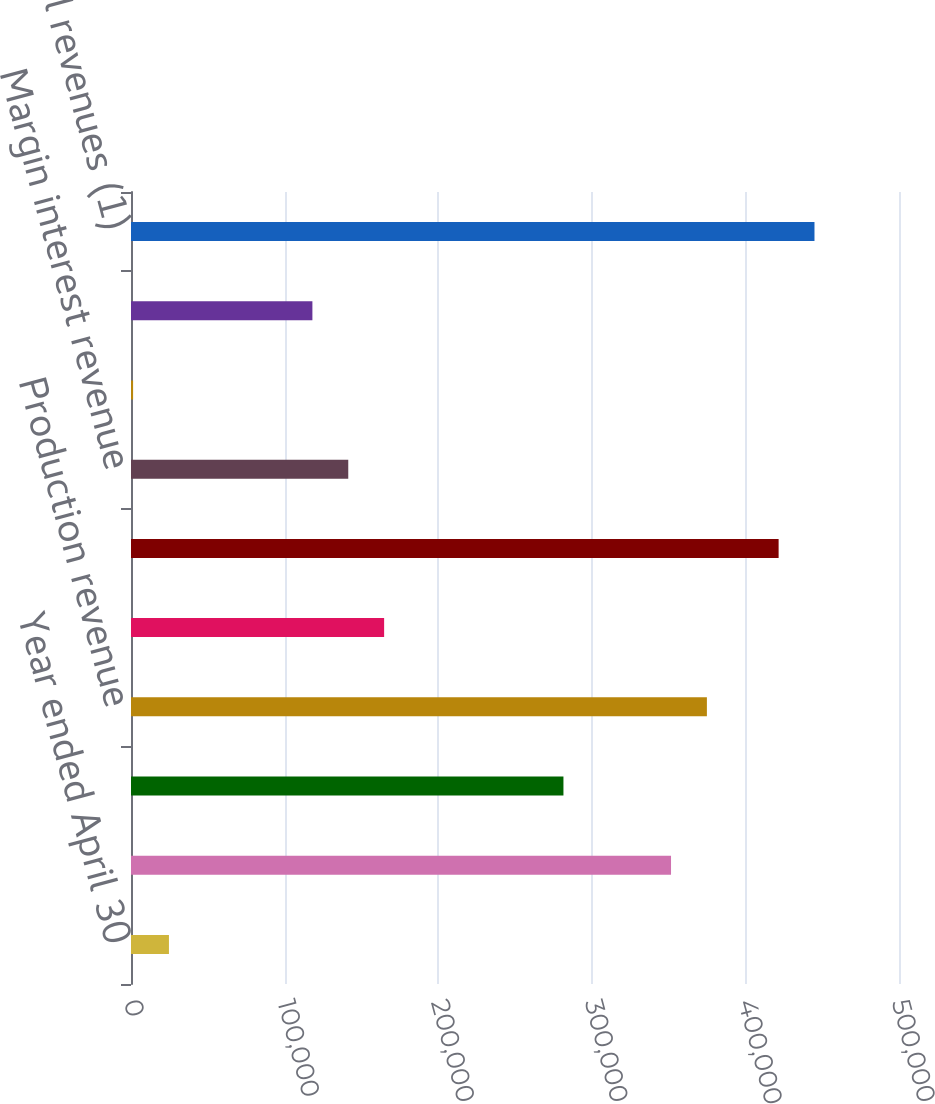Convert chart. <chart><loc_0><loc_0><loc_500><loc_500><bar_chart><fcel>Year ended April 30<fcel>Transactional revenue<fcel>Annuitized revenue<fcel>Production revenue<fcel>Other revenue<fcel>Non-interest revenue<fcel>Margin interest revenue<fcel>Less interest expense<fcel>Net interest revenue<fcel>Total revenues (1)<nl><fcel>24706.3<fcel>351582<fcel>281538<fcel>374931<fcel>164796<fcel>421627<fcel>141448<fcel>1358<fcel>118100<fcel>444976<nl></chart> 